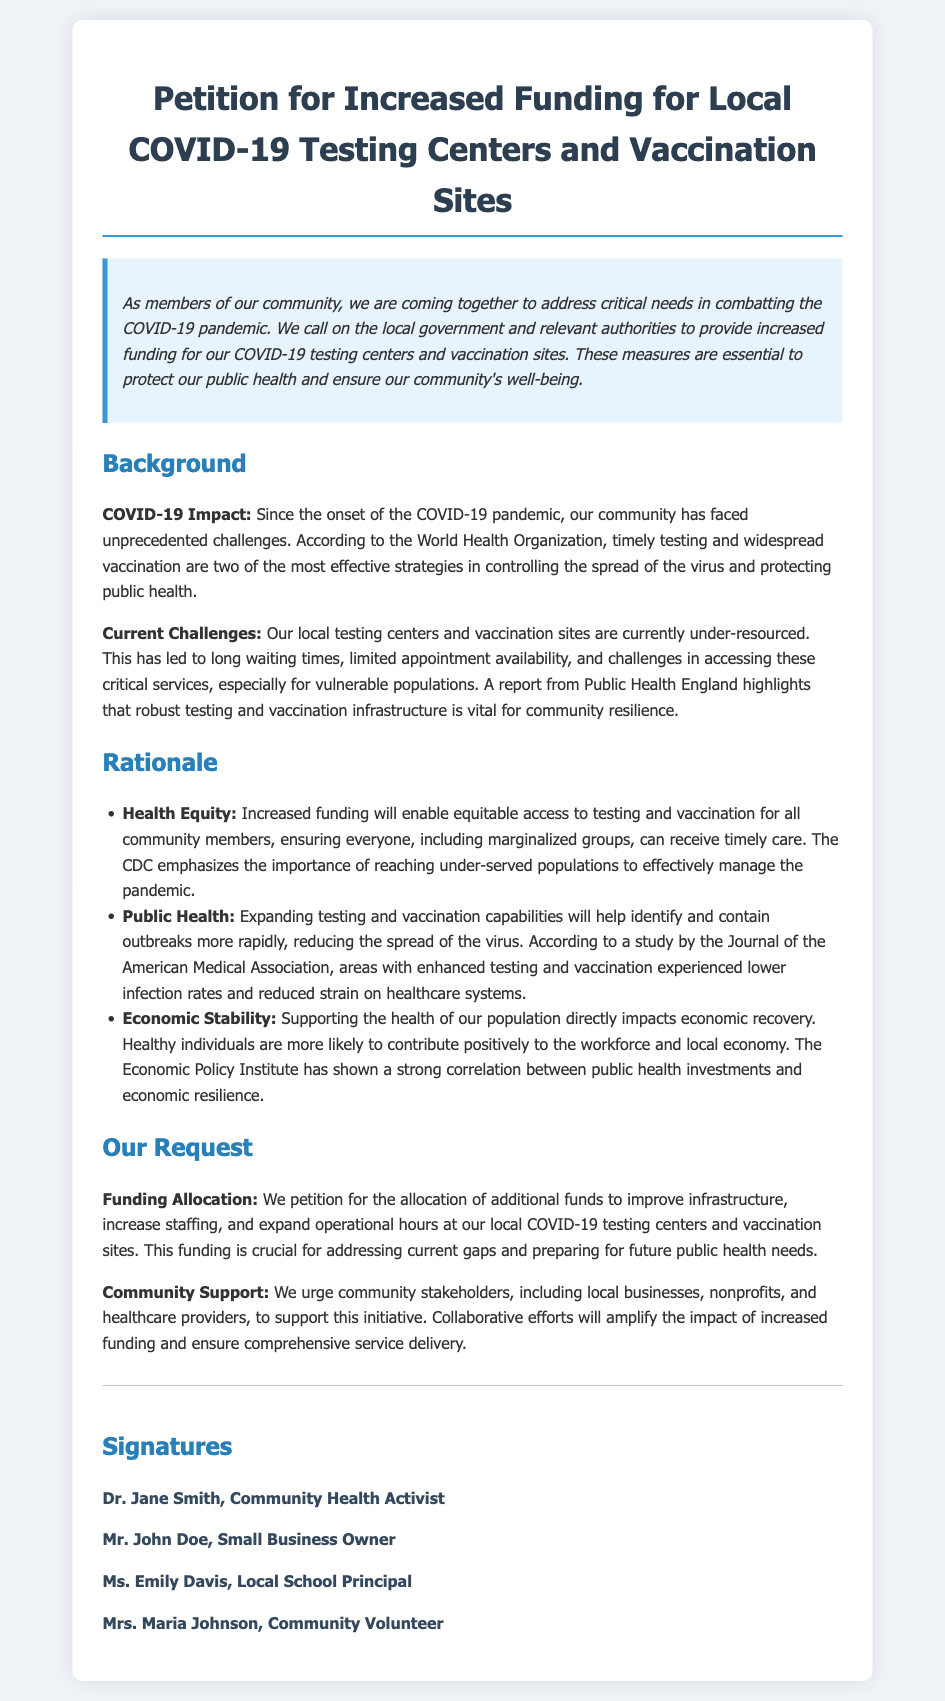What is the title of the petition? The title of the petition is prominently displayed at the top of the document.
Answer: Petition for Increased Funding for Local COVID-19 Testing Centers and Vaccination Sites Who is the community health activist that signed the petition? The document lists Dr. Jane Smith as one of the signers in the signatures section.
Answer: Dr. Jane Smith What is one of the key challenges mentioned regarding local testing centers? The document states the challenge is long waiting times, limited appointment availability, and challenges in accessing services.
Answer: Under-resourced Which organization emphasizes the importance of reaching under-served populations? The document indicates that the CDC emphasizes this importance.
Answer: CDC How does the petition propose to improve local testing centers? The petition requests additional funds for infrastructure improvements and staffing.
Answer: Funding Allocation What impact does public health investment have on the economy according to the document? The document mentions a correlation between public health investments and economic resilience.
Answer: Economic Stability What section follows the background section in the document? The sections of the document are organized sequentially; after background is the rationale.
Answer: Rationale What is the primary purpose of the petition? The petition's primary purpose is to address funding needs for COVID-19 testing and vaccination.
Answer: Increased funding 